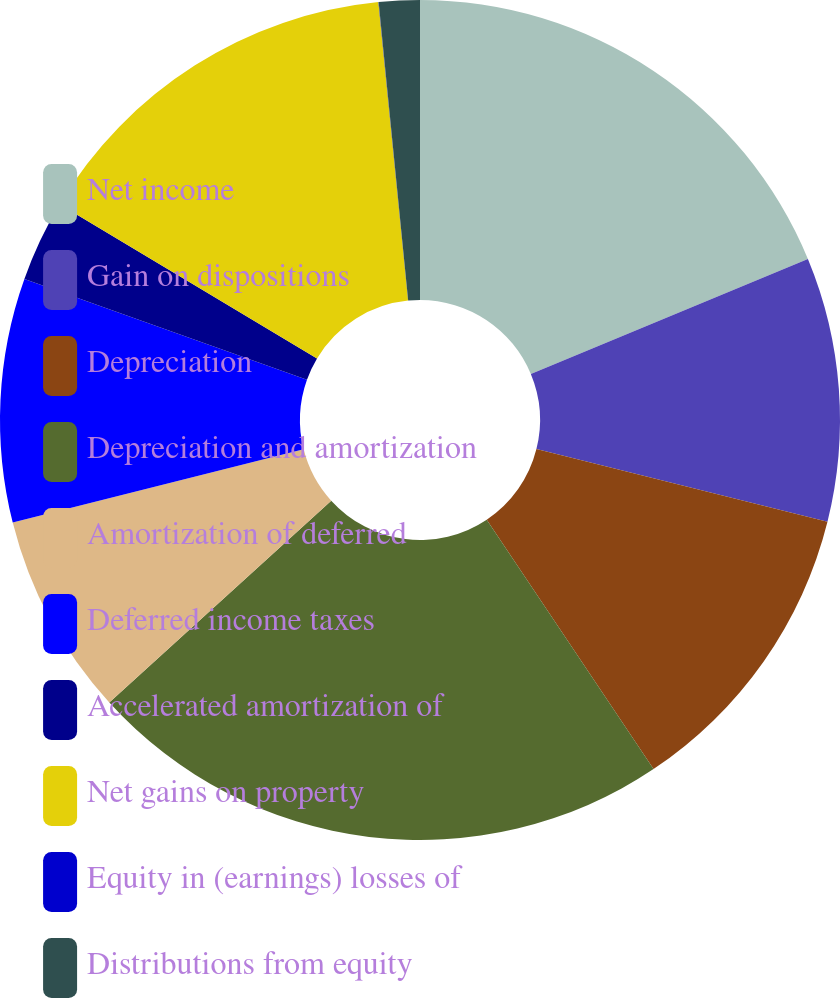Convert chart to OTSL. <chart><loc_0><loc_0><loc_500><loc_500><pie_chart><fcel>Net income<fcel>Gain on dispositions<fcel>Depreciation<fcel>Depreciation and amortization<fcel>Amortization of deferred<fcel>Deferred income taxes<fcel>Accelerated amortization of<fcel>Net gains on property<fcel>Equity in (earnings) losses of<fcel>Distributions from equity<nl><fcel>18.74%<fcel>10.16%<fcel>11.72%<fcel>22.64%<fcel>7.82%<fcel>9.38%<fcel>3.13%<fcel>14.84%<fcel>0.01%<fcel>1.57%<nl></chart> 